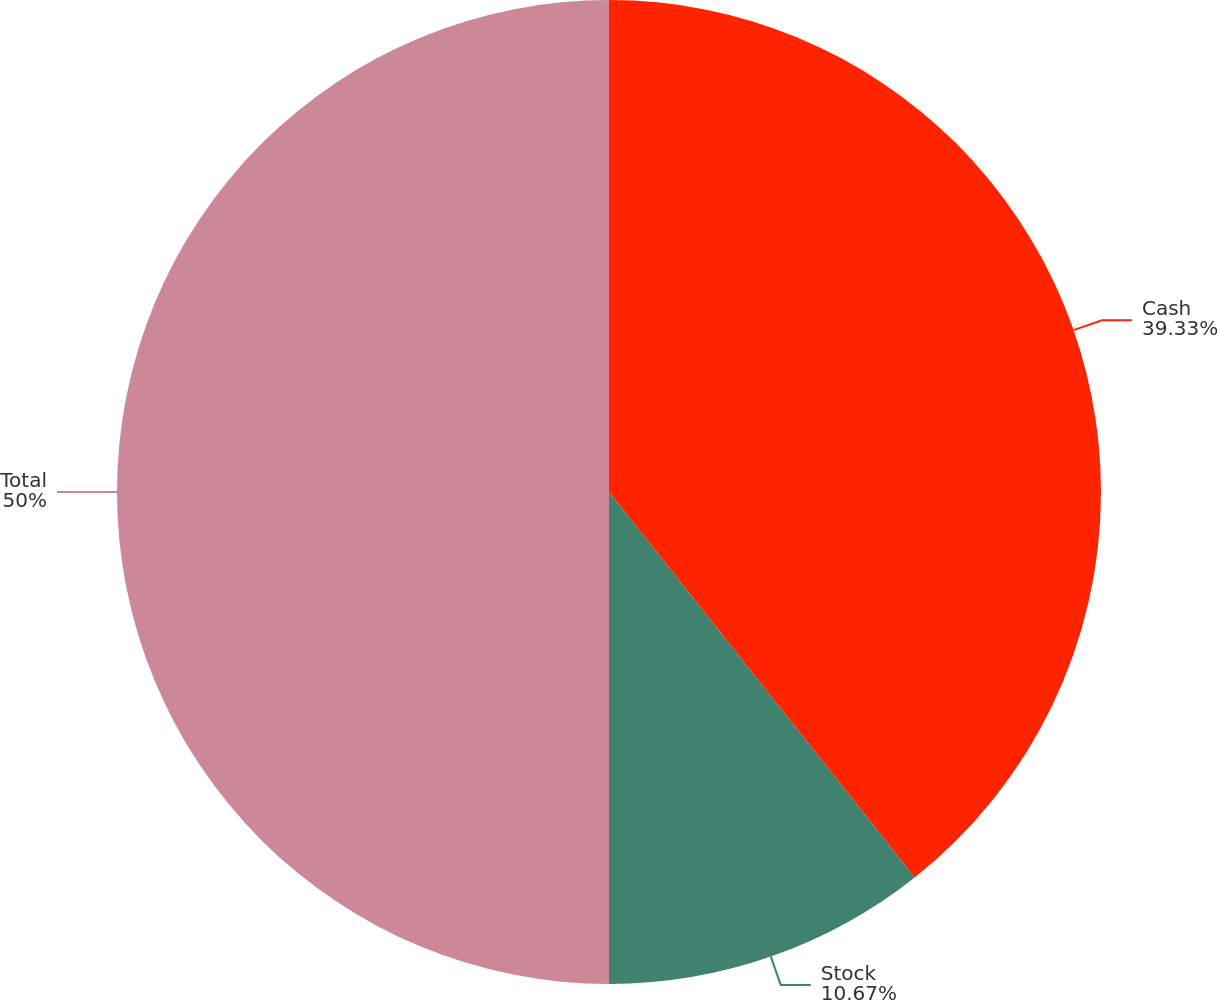Convert chart. <chart><loc_0><loc_0><loc_500><loc_500><pie_chart><fcel>Cash<fcel>Stock<fcel>Total<nl><fcel>39.33%<fcel>10.67%<fcel>50.0%<nl></chart> 